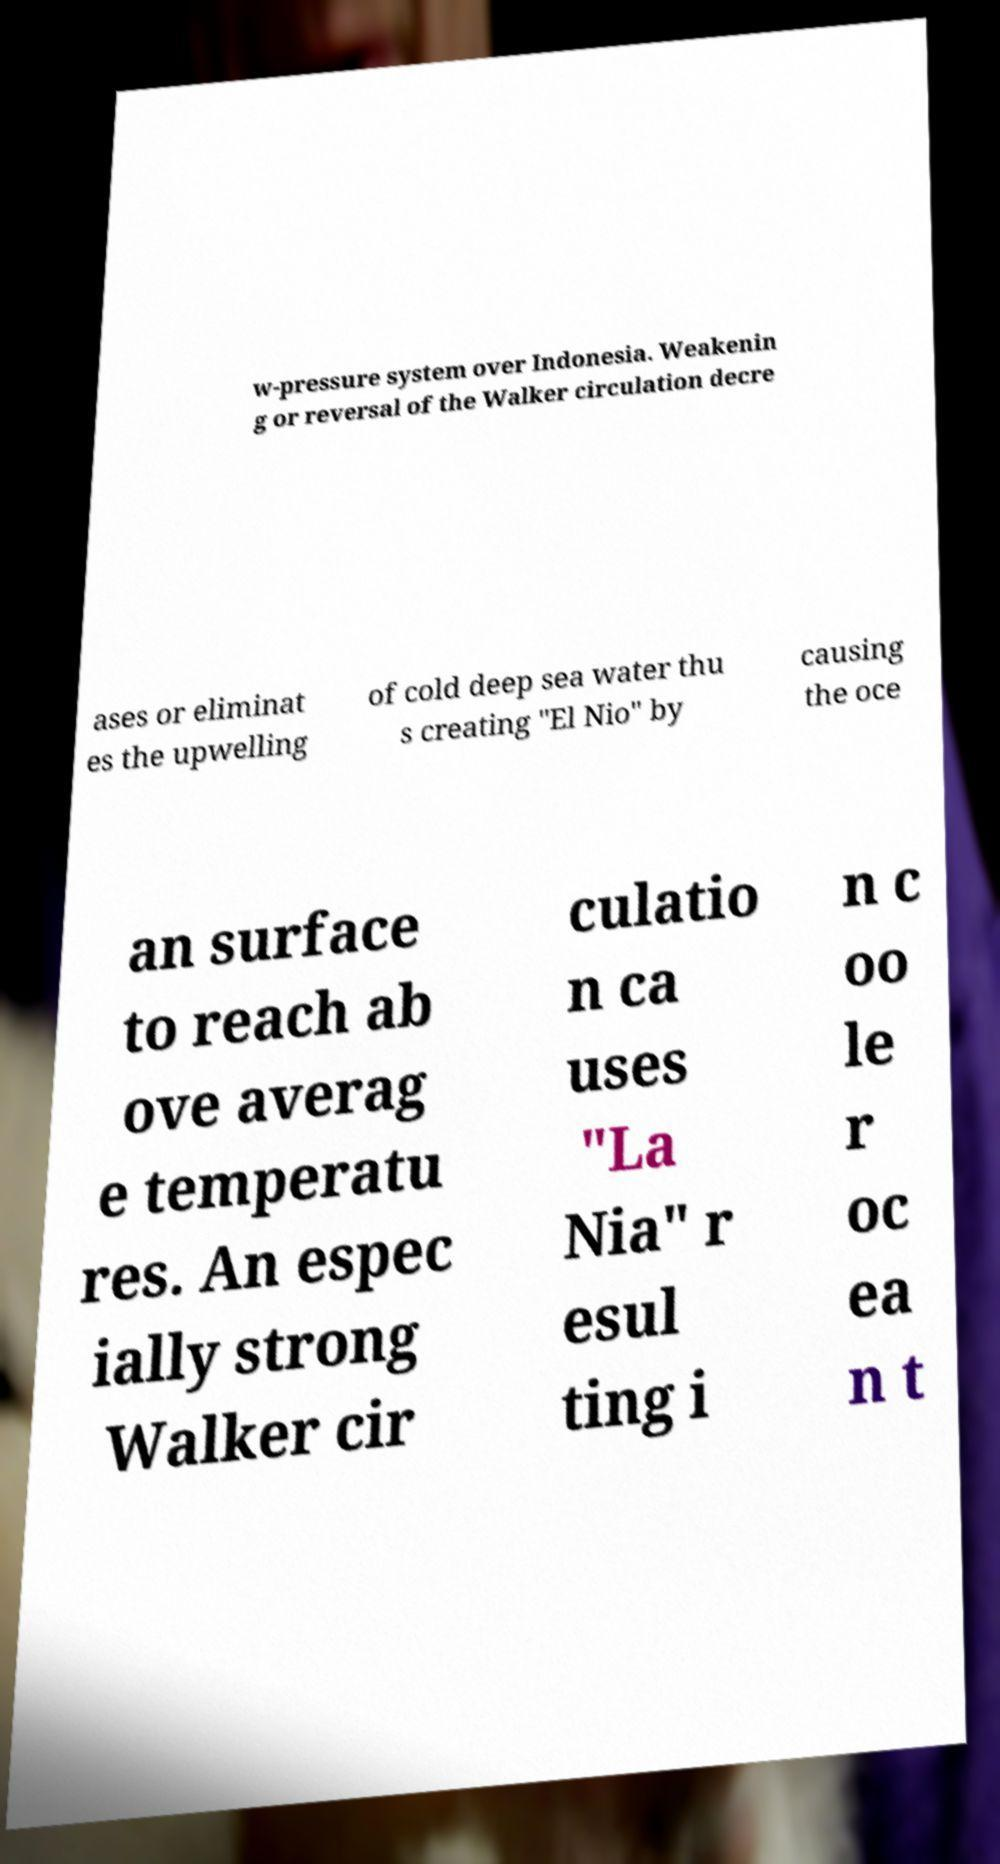Can you read and provide the text displayed in the image?This photo seems to have some interesting text. Can you extract and type it out for me? w-pressure system over Indonesia. Weakenin g or reversal of the Walker circulation decre ases or eliminat es the upwelling of cold deep sea water thu s creating "El Nio" by causing the oce an surface to reach ab ove averag e temperatu res. An espec ially strong Walker cir culatio n ca uses "La Nia" r esul ting i n c oo le r oc ea n t 